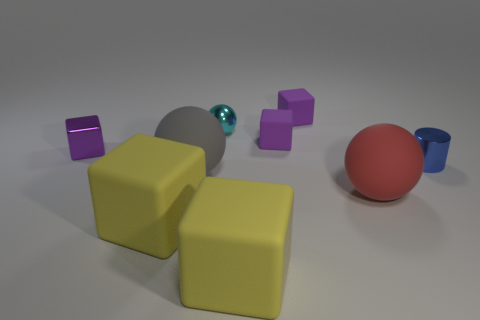Subtract all gray spheres. How many purple cubes are left? 3 Subtract all tiny shiny cubes. How many cubes are left? 4 Subtract 1 blocks. How many blocks are left? 4 Add 1 big blue cylinders. How many objects exist? 10 Subtract all cyan cubes. Subtract all green cylinders. How many cubes are left? 5 Subtract all cylinders. How many objects are left? 8 Subtract 0 green balls. How many objects are left? 9 Subtract all small yellow matte cylinders. Subtract all big matte spheres. How many objects are left? 7 Add 6 purple metallic blocks. How many purple metallic blocks are left? 7 Add 3 big yellow rubber cylinders. How many big yellow rubber cylinders exist? 3 